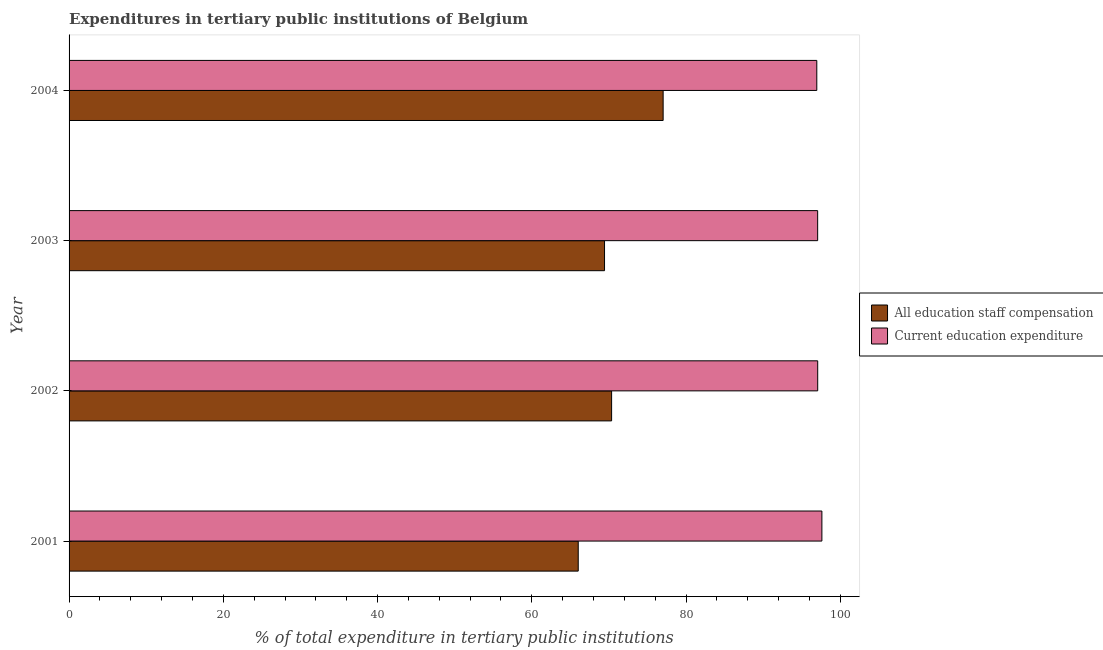How many different coloured bars are there?
Ensure brevity in your answer.  2. How many groups of bars are there?
Offer a very short reply. 4. Are the number of bars per tick equal to the number of legend labels?
Provide a short and direct response. Yes. Are the number of bars on each tick of the Y-axis equal?
Your response must be concise. Yes. How many bars are there on the 3rd tick from the top?
Give a very brief answer. 2. What is the label of the 1st group of bars from the top?
Make the answer very short. 2004. What is the expenditure in staff compensation in 2004?
Give a very brief answer. 77.02. Across all years, what is the maximum expenditure in education?
Offer a very short reply. 97.61. Across all years, what is the minimum expenditure in staff compensation?
Ensure brevity in your answer.  66.02. What is the total expenditure in staff compensation in the graph?
Provide a short and direct response. 282.81. What is the difference between the expenditure in staff compensation in 2002 and that in 2004?
Your answer should be very brief. -6.68. What is the difference between the expenditure in education in 2003 and the expenditure in staff compensation in 2001?
Your answer should be very brief. 31.04. What is the average expenditure in education per year?
Ensure brevity in your answer.  97.17. In the year 2003, what is the difference between the expenditure in staff compensation and expenditure in education?
Make the answer very short. -27.63. What is the ratio of the expenditure in education in 2001 to that in 2004?
Keep it short and to the point. 1.01. Is the expenditure in education in 2003 less than that in 2004?
Offer a very short reply. No. What is the difference between the highest and the second highest expenditure in staff compensation?
Your answer should be very brief. 6.68. What is the difference between the highest and the lowest expenditure in staff compensation?
Keep it short and to the point. 11.01. In how many years, is the expenditure in staff compensation greater than the average expenditure in staff compensation taken over all years?
Your response must be concise. 1. Is the sum of the expenditure in staff compensation in 2003 and 2004 greater than the maximum expenditure in education across all years?
Your response must be concise. Yes. What does the 2nd bar from the top in 2001 represents?
Give a very brief answer. All education staff compensation. What does the 2nd bar from the bottom in 2004 represents?
Give a very brief answer. Current education expenditure. How many bars are there?
Ensure brevity in your answer.  8. Are all the bars in the graph horizontal?
Offer a very short reply. Yes. What is the difference between two consecutive major ticks on the X-axis?
Provide a succinct answer. 20. Are the values on the major ticks of X-axis written in scientific E-notation?
Ensure brevity in your answer.  No. Does the graph contain any zero values?
Give a very brief answer. No. Does the graph contain grids?
Your answer should be compact. No. How many legend labels are there?
Keep it short and to the point. 2. What is the title of the graph?
Give a very brief answer. Expenditures in tertiary public institutions of Belgium. What is the label or title of the X-axis?
Give a very brief answer. % of total expenditure in tertiary public institutions. What is the label or title of the Y-axis?
Keep it short and to the point. Year. What is the % of total expenditure in tertiary public institutions of All education staff compensation in 2001?
Give a very brief answer. 66.02. What is the % of total expenditure in tertiary public institutions in Current education expenditure in 2001?
Keep it short and to the point. 97.61. What is the % of total expenditure in tertiary public institutions in All education staff compensation in 2002?
Provide a succinct answer. 70.34. What is the % of total expenditure in tertiary public institutions of Current education expenditure in 2002?
Your response must be concise. 97.06. What is the % of total expenditure in tertiary public institutions in All education staff compensation in 2003?
Provide a short and direct response. 69.43. What is the % of total expenditure in tertiary public institutions in Current education expenditure in 2003?
Your answer should be very brief. 97.06. What is the % of total expenditure in tertiary public institutions in All education staff compensation in 2004?
Your answer should be very brief. 77.02. What is the % of total expenditure in tertiary public institutions of Current education expenditure in 2004?
Offer a terse response. 96.95. Across all years, what is the maximum % of total expenditure in tertiary public institutions in All education staff compensation?
Provide a short and direct response. 77.02. Across all years, what is the maximum % of total expenditure in tertiary public institutions of Current education expenditure?
Your response must be concise. 97.61. Across all years, what is the minimum % of total expenditure in tertiary public institutions of All education staff compensation?
Keep it short and to the point. 66.02. Across all years, what is the minimum % of total expenditure in tertiary public institutions of Current education expenditure?
Keep it short and to the point. 96.95. What is the total % of total expenditure in tertiary public institutions in All education staff compensation in the graph?
Offer a very short reply. 282.81. What is the total % of total expenditure in tertiary public institutions of Current education expenditure in the graph?
Provide a succinct answer. 388.68. What is the difference between the % of total expenditure in tertiary public institutions in All education staff compensation in 2001 and that in 2002?
Your answer should be very brief. -4.33. What is the difference between the % of total expenditure in tertiary public institutions of Current education expenditure in 2001 and that in 2002?
Make the answer very short. 0.54. What is the difference between the % of total expenditure in tertiary public institutions in All education staff compensation in 2001 and that in 2003?
Give a very brief answer. -3.41. What is the difference between the % of total expenditure in tertiary public institutions of Current education expenditure in 2001 and that in 2003?
Ensure brevity in your answer.  0.55. What is the difference between the % of total expenditure in tertiary public institutions in All education staff compensation in 2001 and that in 2004?
Give a very brief answer. -11.01. What is the difference between the % of total expenditure in tertiary public institutions of Current education expenditure in 2001 and that in 2004?
Provide a succinct answer. 0.66. What is the difference between the % of total expenditure in tertiary public institutions of All education staff compensation in 2002 and that in 2003?
Your answer should be compact. 0.92. What is the difference between the % of total expenditure in tertiary public institutions of Current education expenditure in 2002 and that in 2003?
Make the answer very short. 0.01. What is the difference between the % of total expenditure in tertiary public institutions of All education staff compensation in 2002 and that in 2004?
Provide a short and direct response. -6.68. What is the difference between the % of total expenditure in tertiary public institutions of Current education expenditure in 2002 and that in 2004?
Provide a short and direct response. 0.12. What is the difference between the % of total expenditure in tertiary public institutions of All education staff compensation in 2003 and that in 2004?
Your answer should be compact. -7.6. What is the difference between the % of total expenditure in tertiary public institutions of Current education expenditure in 2003 and that in 2004?
Provide a succinct answer. 0.11. What is the difference between the % of total expenditure in tertiary public institutions of All education staff compensation in 2001 and the % of total expenditure in tertiary public institutions of Current education expenditure in 2002?
Give a very brief answer. -31.05. What is the difference between the % of total expenditure in tertiary public institutions in All education staff compensation in 2001 and the % of total expenditure in tertiary public institutions in Current education expenditure in 2003?
Offer a terse response. -31.04. What is the difference between the % of total expenditure in tertiary public institutions in All education staff compensation in 2001 and the % of total expenditure in tertiary public institutions in Current education expenditure in 2004?
Keep it short and to the point. -30.93. What is the difference between the % of total expenditure in tertiary public institutions of All education staff compensation in 2002 and the % of total expenditure in tertiary public institutions of Current education expenditure in 2003?
Your answer should be very brief. -26.71. What is the difference between the % of total expenditure in tertiary public institutions of All education staff compensation in 2002 and the % of total expenditure in tertiary public institutions of Current education expenditure in 2004?
Keep it short and to the point. -26.6. What is the difference between the % of total expenditure in tertiary public institutions of All education staff compensation in 2003 and the % of total expenditure in tertiary public institutions of Current education expenditure in 2004?
Keep it short and to the point. -27.52. What is the average % of total expenditure in tertiary public institutions of All education staff compensation per year?
Make the answer very short. 70.7. What is the average % of total expenditure in tertiary public institutions of Current education expenditure per year?
Provide a succinct answer. 97.17. In the year 2001, what is the difference between the % of total expenditure in tertiary public institutions of All education staff compensation and % of total expenditure in tertiary public institutions of Current education expenditure?
Ensure brevity in your answer.  -31.59. In the year 2002, what is the difference between the % of total expenditure in tertiary public institutions in All education staff compensation and % of total expenditure in tertiary public institutions in Current education expenditure?
Offer a terse response. -26.72. In the year 2003, what is the difference between the % of total expenditure in tertiary public institutions in All education staff compensation and % of total expenditure in tertiary public institutions in Current education expenditure?
Provide a short and direct response. -27.63. In the year 2004, what is the difference between the % of total expenditure in tertiary public institutions of All education staff compensation and % of total expenditure in tertiary public institutions of Current education expenditure?
Offer a very short reply. -19.92. What is the ratio of the % of total expenditure in tertiary public institutions of All education staff compensation in 2001 to that in 2002?
Offer a very short reply. 0.94. What is the ratio of the % of total expenditure in tertiary public institutions of Current education expenditure in 2001 to that in 2002?
Offer a very short reply. 1.01. What is the ratio of the % of total expenditure in tertiary public institutions of All education staff compensation in 2001 to that in 2003?
Keep it short and to the point. 0.95. What is the ratio of the % of total expenditure in tertiary public institutions of Current education expenditure in 2001 to that in 2003?
Ensure brevity in your answer.  1.01. What is the ratio of the % of total expenditure in tertiary public institutions of Current education expenditure in 2001 to that in 2004?
Provide a succinct answer. 1.01. What is the ratio of the % of total expenditure in tertiary public institutions of All education staff compensation in 2002 to that in 2003?
Your answer should be compact. 1.01. What is the ratio of the % of total expenditure in tertiary public institutions in Current education expenditure in 2002 to that in 2003?
Your answer should be compact. 1. What is the ratio of the % of total expenditure in tertiary public institutions in All education staff compensation in 2002 to that in 2004?
Offer a terse response. 0.91. What is the ratio of the % of total expenditure in tertiary public institutions of Current education expenditure in 2002 to that in 2004?
Provide a succinct answer. 1. What is the ratio of the % of total expenditure in tertiary public institutions in All education staff compensation in 2003 to that in 2004?
Your answer should be compact. 0.9. What is the ratio of the % of total expenditure in tertiary public institutions of Current education expenditure in 2003 to that in 2004?
Provide a succinct answer. 1. What is the difference between the highest and the second highest % of total expenditure in tertiary public institutions of All education staff compensation?
Give a very brief answer. 6.68. What is the difference between the highest and the second highest % of total expenditure in tertiary public institutions of Current education expenditure?
Keep it short and to the point. 0.54. What is the difference between the highest and the lowest % of total expenditure in tertiary public institutions of All education staff compensation?
Your response must be concise. 11.01. What is the difference between the highest and the lowest % of total expenditure in tertiary public institutions in Current education expenditure?
Make the answer very short. 0.66. 